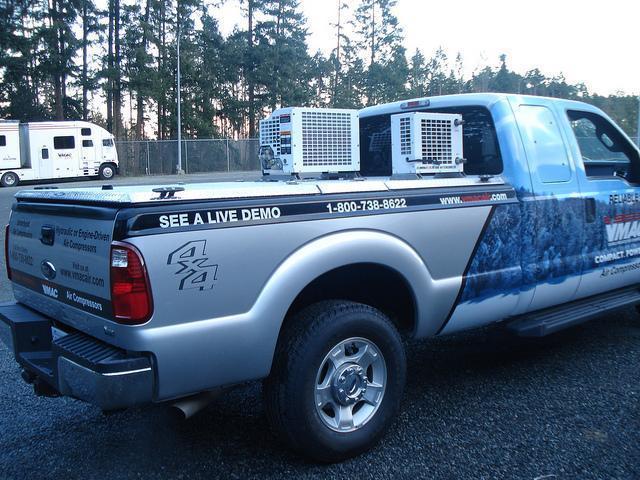How many people wearing red shirt?
Give a very brief answer. 0. 